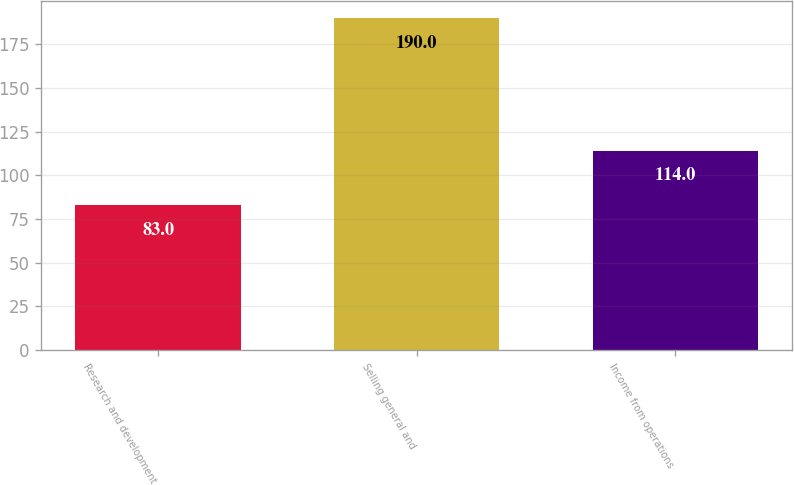Convert chart to OTSL. <chart><loc_0><loc_0><loc_500><loc_500><bar_chart><fcel>Research and development<fcel>Selling general and<fcel>Income from operations<nl><fcel>83<fcel>190<fcel>114<nl></chart> 